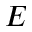<formula> <loc_0><loc_0><loc_500><loc_500>E</formula> 